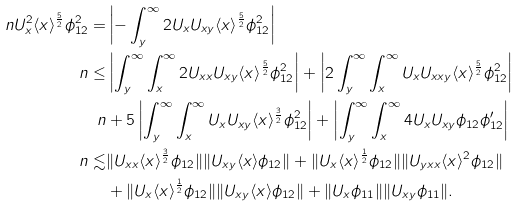<formula> <loc_0><loc_0><loc_500><loc_500>\ n U _ { x } ^ { 2 } \langle x \rangle ^ { \frac { 5 } { 2 } } \phi _ { 1 2 } ^ { 2 } = & \left | - \int _ { y } ^ { \infty } 2 U _ { x } U _ { x y } \langle x \rangle ^ { \frac { 5 } { 2 } } \phi _ { 1 2 } ^ { 2 } \right | \\ \ n \leq & \left | \int _ { y } ^ { \infty } \int _ { x } ^ { \infty } 2 U _ { x x } U _ { x y } \langle x \rangle ^ { \frac { 5 } { 2 } } \phi _ { 1 2 } ^ { 2 } \right | + \left | 2 \int _ { y } ^ { \infty } \int _ { x } ^ { \infty } U _ { x } U _ { x x y } \langle x \rangle ^ { \frac { 5 } { 2 } } \phi _ { 1 2 } ^ { 2 } \right | \\ \ n & + 5 \left | \int _ { y } ^ { \infty } \int _ { x } ^ { \infty } U _ { x } U _ { x y } \langle x \rangle ^ { \frac { 3 } { 2 } } \phi _ { 1 2 } ^ { 2 } \right | + \left | \int _ { y } ^ { \infty } \int _ { x } ^ { \infty } 4 U _ { x } U _ { x y } \phi _ { 1 2 } \phi _ { 1 2 } ^ { \prime } \right | \\ \ n \lesssim & \| U _ { x x } \langle x \rangle ^ { \frac { 3 } { 2 } } \phi _ { 1 2 } \| \| U _ { x y } \langle x \rangle \phi _ { 1 2 } \| + \| U _ { x } \langle x \rangle ^ { \frac { 1 } { 2 } } \phi _ { 1 2 } \| \| U _ { y x x } \langle x \rangle ^ { 2 } \phi _ { 1 2 } \| \\ & + \| U _ { x } \langle x \rangle ^ { \frac { 1 } { 2 } } \phi _ { 1 2 } \| \| U _ { x y } \langle x \rangle \phi _ { 1 2 } \| + \| U _ { x } \phi _ { 1 1 } \| \| U _ { x y } \phi _ { 1 1 } \| .</formula> 